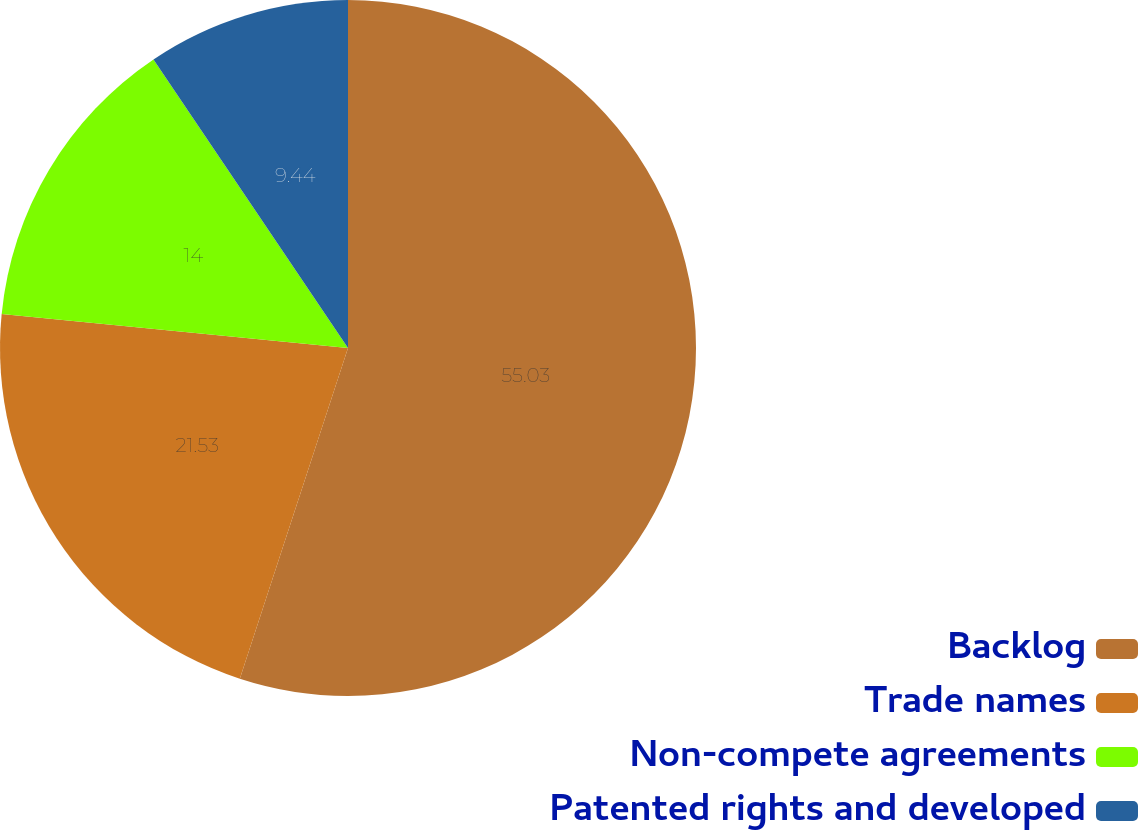Convert chart to OTSL. <chart><loc_0><loc_0><loc_500><loc_500><pie_chart><fcel>Backlog<fcel>Trade names<fcel>Non-compete agreements<fcel>Patented rights and developed<nl><fcel>55.03%<fcel>21.53%<fcel>14.0%<fcel>9.44%<nl></chart> 